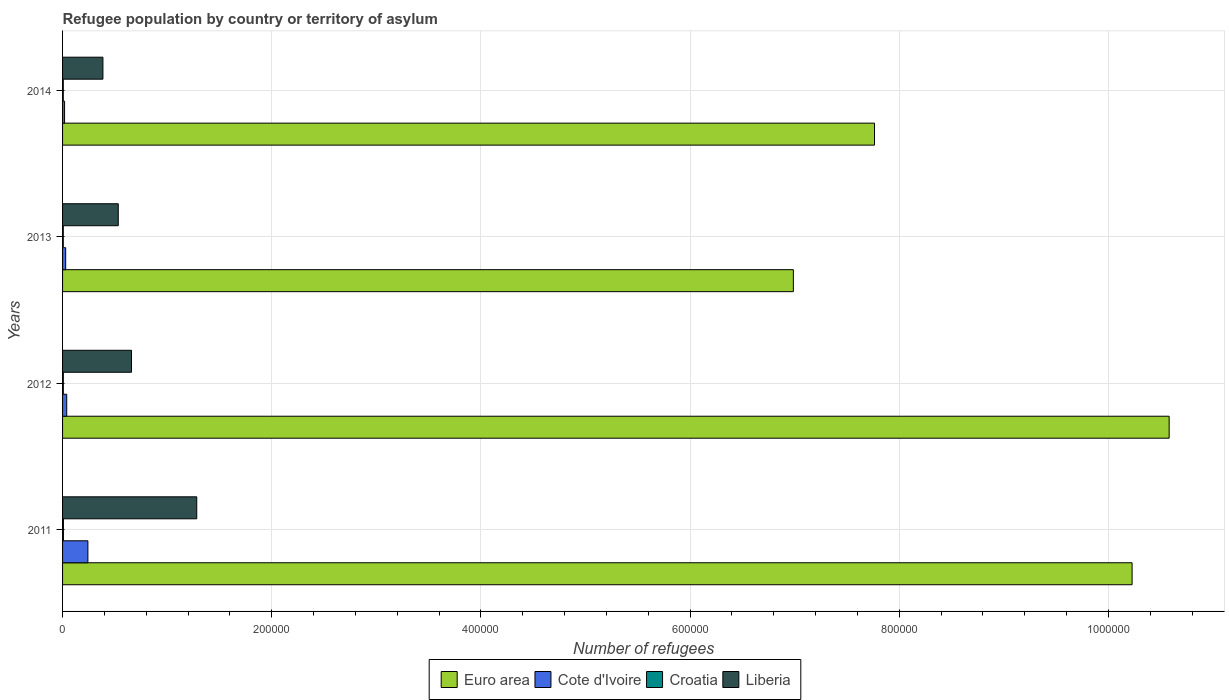How many groups of bars are there?
Offer a very short reply. 4. Are the number of bars per tick equal to the number of legend labels?
Provide a short and direct response. Yes. Are the number of bars on each tick of the Y-axis equal?
Ensure brevity in your answer.  Yes. How many bars are there on the 1st tick from the top?
Offer a terse response. 4. How many bars are there on the 1st tick from the bottom?
Give a very brief answer. 4. In how many cases, is the number of bars for a given year not equal to the number of legend labels?
Offer a terse response. 0. What is the number of refugees in Cote d'Ivoire in 2012?
Provide a short and direct response. 3980. Across all years, what is the maximum number of refugees in Euro area?
Make the answer very short. 1.06e+06. Across all years, what is the minimum number of refugees in Croatia?
Ensure brevity in your answer.  679. What is the total number of refugees in Liberia in the graph?
Your answer should be compact. 2.86e+05. What is the difference between the number of refugees in Croatia in 2011 and that in 2012?
Offer a very short reply. 100. What is the difference between the number of refugees in Cote d'Ivoire in 2011 and the number of refugees in Liberia in 2014?
Give a very brief answer. -1.44e+04. What is the average number of refugees in Cote d'Ivoire per year?
Make the answer very short. 8276.5. In the year 2011, what is the difference between the number of refugees in Cote d'Ivoire and number of refugees in Croatia?
Your answer should be very brief. 2.34e+04. What is the ratio of the number of refugees in Euro area in 2011 to that in 2014?
Provide a succinct answer. 1.32. Is the number of refugees in Euro area in 2012 less than that in 2013?
Your answer should be compact. No. Is the difference between the number of refugees in Cote d'Ivoire in 2011 and 2013 greater than the difference between the number of refugees in Croatia in 2011 and 2013?
Give a very brief answer. Yes. What is the difference between the highest and the second highest number of refugees in Euro area?
Offer a very short reply. 3.54e+04. What is the difference between the highest and the lowest number of refugees in Cote d'Ivoire?
Keep it short and to the point. 2.23e+04. In how many years, is the number of refugees in Croatia greater than the average number of refugees in Croatia taken over all years?
Make the answer very short. 1. What does the 2nd bar from the top in 2013 represents?
Ensure brevity in your answer.  Croatia. What does the 1st bar from the bottom in 2011 represents?
Offer a terse response. Euro area. Is it the case that in every year, the sum of the number of refugees in Croatia and number of refugees in Liberia is greater than the number of refugees in Euro area?
Give a very brief answer. No. How many bars are there?
Offer a terse response. 16. Are all the bars in the graph horizontal?
Give a very brief answer. Yes. What is the difference between two consecutive major ticks on the X-axis?
Offer a very short reply. 2.00e+05. Does the graph contain grids?
Your answer should be very brief. Yes. What is the title of the graph?
Provide a short and direct response. Refugee population by country or territory of asylum. What is the label or title of the X-axis?
Ensure brevity in your answer.  Number of refugees. What is the Number of refugees in Euro area in 2011?
Ensure brevity in your answer.  1.02e+06. What is the Number of refugees of Cote d'Ivoire in 2011?
Offer a terse response. 2.42e+04. What is the Number of refugees in Croatia in 2011?
Keep it short and to the point. 824. What is the Number of refugees in Liberia in 2011?
Your response must be concise. 1.28e+05. What is the Number of refugees in Euro area in 2012?
Offer a terse response. 1.06e+06. What is the Number of refugees of Cote d'Ivoire in 2012?
Ensure brevity in your answer.  3980. What is the Number of refugees of Croatia in 2012?
Your answer should be very brief. 724. What is the Number of refugees of Liberia in 2012?
Your response must be concise. 6.59e+04. What is the Number of refugees in Euro area in 2013?
Offer a very short reply. 6.99e+05. What is the Number of refugees of Cote d'Ivoire in 2013?
Keep it short and to the point. 2980. What is the Number of refugees in Croatia in 2013?
Ensure brevity in your answer.  684. What is the Number of refugees in Liberia in 2013?
Your answer should be very brief. 5.33e+04. What is the Number of refugees in Euro area in 2014?
Provide a short and direct response. 7.76e+05. What is the Number of refugees of Cote d'Ivoire in 2014?
Make the answer very short. 1925. What is the Number of refugees of Croatia in 2014?
Keep it short and to the point. 679. What is the Number of refugees of Liberia in 2014?
Keep it short and to the point. 3.86e+04. Across all years, what is the maximum Number of refugees in Euro area?
Make the answer very short. 1.06e+06. Across all years, what is the maximum Number of refugees in Cote d'Ivoire?
Make the answer very short. 2.42e+04. Across all years, what is the maximum Number of refugees of Croatia?
Make the answer very short. 824. Across all years, what is the maximum Number of refugees in Liberia?
Keep it short and to the point. 1.28e+05. Across all years, what is the minimum Number of refugees in Euro area?
Keep it short and to the point. 6.99e+05. Across all years, what is the minimum Number of refugees in Cote d'Ivoire?
Your response must be concise. 1925. Across all years, what is the minimum Number of refugees in Croatia?
Give a very brief answer. 679. Across all years, what is the minimum Number of refugees of Liberia?
Provide a succinct answer. 3.86e+04. What is the total Number of refugees in Euro area in the graph?
Ensure brevity in your answer.  3.56e+06. What is the total Number of refugees of Cote d'Ivoire in the graph?
Your answer should be compact. 3.31e+04. What is the total Number of refugees of Croatia in the graph?
Offer a very short reply. 2911. What is the total Number of refugees of Liberia in the graph?
Your response must be concise. 2.86e+05. What is the difference between the Number of refugees in Euro area in 2011 and that in 2012?
Provide a succinct answer. -3.54e+04. What is the difference between the Number of refugees of Cote d'Ivoire in 2011 and that in 2012?
Your response must be concise. 2.02e+04. What is the difference between the Number of refugees in Liberia in 2011 and that in 2012?
Your response must be concise. 6.24e+04. What is the difference between the Number of refugees of Euro area in 2011 and that in 2013?
Your response must be concise. 3.24e+05. What is the difference between the Number of refugees of Cote d'Ivoire in 2011 and that in 2013?
Keep it short and to the point. 2.12e+04. What is the difference between the Number of refugees of Croatia in 2011 and that in 2013?
Offer a very short reply. 140. What is the difference between the Number of refugees in Liberia in 2011 and that in 2013?
Ensure brevity in your answer.  7.50e+04. What is the difference between the Number of refugees of Euro area in 2011 and that in 2014?
Keep it short and to the point. 2.46e+05. What is the difference between the Number of refugees of Cote d'Ivoire in 2011 and that in 2014?
Provide a short and direct response. 2.23e+04. What is the difference between the Number of refugees in Croatia in 2011 and that in 2014?
Your response must be concise. 145. What is the difference between the Number of refugees of Liberia in 2011 and that in 2014?
Provide a short and direct response. 8.97e+04. What is the difference between the Number of refugees of Euro area in 2012 and that in 2013?
Provide a short and direct response. 3.59e+05. What is the difference between the Number of refugees of Croatia in 2012 and that in 2013?
Your response must be concise. 40. What is the difference between the Number of refugees in Liberia in 2012 and that in 2013?
Provide a short and direct response. 1.27e+04. What is the difference between the Number of refugees in Euro area in 2012 and that in 2014?
Your answer should be very brief. 2.82e+05. What is the difference between the Number of refugees of Cote d'Ivoire in 2012 and that in 2014?
Make the answer very short. 2055. What is the difference between the Number of refugees in Liberia in 2012 and that in 2014?
Offer a very short reply. 2.73e+04. What is the difference between the Number of refugees of Euro area in 2013 and that in 2014?
Offer a terse response. -7.76e+04. What is the difference between the Number of refugees of Cote d'Ivoire in 2013 and that in 2014?
Keep it short and to the point. 1055. What is the difference between the Number of refugees of Croatia in 2013 and that in 2014?
Ensure brevity in your answer.  5. What is the difference between the Number of refugees of Liberia in 2013 and that in 2014?
Offer a terse response. 1.47e+04. What is the difference between the Number of refugees in Euro area in 2011 and the Number of refugees in Cote d'Ivoire in 2012?
Give a very brief answer. 1.02e+06. What is the difference between the Number of refugees in Euro area in 2011 and the Number of refugees in Croatia in 2012?
Provide a short and direct response. 1.02e+06. What is the difference between the Number of refugees of Euro area in 2011 and the Number of refugees of Liberia in 2012?
Your answer should be very brief. 9.57e+05. What is the difference between the Number of refugees of Cote d'Ivoire in 2011 and the Number of refugees of Croatia in 2012?
Offer a very short reply. 2.35e+04. What is the difference between the Number of refugees in Cote d'Ivoire in 2011 and the Number of refugees in Liberia in 2012?
Your response must be concise. -4.17e+04. What is the difference between the Number of refugees in Croatia in 2011 and the Number of refugees in Liberia in 2012?
Provide a succinct answer. -6.51e+04. What is the difference between the Number of refugees of Euro area in 2011 and the Number of refugees of Cote d'Ivoire in 2013?
Your answer should be very brief. 1.02e+06. What is the difference between the Number of refugees in Euro area in 2011 and the Number of refugees in Croatia in 2013?
Your answer should be compact. 1.02e+06. What is the difference between the Number of refugees in Euro area in 2011 and the Number of refugees in Liberia in 2013?
Offer a very short reply. 9.69e+05. What is the difference between the Number of refugees in Cote d'Ivoire in 2011 and the Number of refugees in Croatia in 2013?
Offer a terse response. 2.35e+04. What is the difference between the Number of refugees of Cote d'Ivoire in 2011 and the Number of refugees of Liberia in 2013?
Offer a terse response. -2.90e+04. What is the difference between the Number of refugees in Croatia in 2011 and the Number of refugees in Liberia in 2013?
Provide a short and direct response. -5.24e+04. What is the difference between the Number of refugees in Euro area in 2011 and the Number of refugees in Cote d'Ivoire in 2014?
Provide a short and direct response. 1.02e+06. What is the difference between the Number of refugees of Euro area in 2011 and the Number of refugees of Croatia in 2014?
Provide a succinct answer. 1.02e+06. What is the difference between the Number of refugees in Euro area in 2011 and the Number of refugees in Liberia in 2014?
Keep it short and to the point. 9.84e+05. What is the difference between the Number of refugees in Cote d'Ivoire in 2011 and the Number of refugees in Croatia in 2014?
Your response must be concise. 2.35e+04. What is the difference between the Number of refugees in Cote d'Ivoire in 2011 and the Number of refugees in Liberia in 2014?
Ensure brevity in your answer.  -1.44e+04. What is the difference between the Number of refugees of Croatia in 2011 and the Number of refugees of Liberia in 2014?
Keep it short and to the point. -3.78e+04. What is the difference between the Number of refugees of Euro area in 2012 and the Number of refugees of Cote d'Ivoire in 2013?
Your answer should be compact. 1.06e+06. What is the difference between the Number of refugees in Euro area in 2012 and the Number of refugees in Croatia in 2013?
Make the answer very short. 1.06e+06. What is the difference between the Number of refugees of Euro area in 2012 and the Number of refugees of Liberia in 2013?
Offer a terse response. 1.00e+06. What is the difference between the Number of refugees of Cote d'Ivoire in 2012 and the Number of refugees of Croatia in 2013?
Your response must be concise. 3296. What is the difference between the Number of refugees of Cote d'Ivoire in 2012 and the Number of refugees of Liberia in 2013?
Provide a short and direct response. -4.93e+04. What is the difference between the Number of refugees in Croatia in 2012 and the Number of refugees in Liberia in 2013?
Offer a terse response. -5.25e+04. What is the difference between the Number of refugees of Euro area in 2012 and the Number of refugees of Cote d'Ivoire in 2014?
Ensure brevity in your answer.  1.06e+06. What is the difference between the Number of refugees in Euro area in 2012 and the Number of refugees in Croatia in 2014?
Keep it short and to the point. 1.06e+06. What is the difference between the Number of refugees of Euro area in 2012 and the Number of refugees of Liberia in 2014?
Keep it short and to the point. 1.02e+06. What is the difference between the Number of refugees in Cote d'Ivoire in 2012 and the Number of refugees in Croatia in 2014?
Provide a succinct answer. 3301. What is the difference between the Number of refugees of Cote d'Ivoire in 2012 and the Number of refugees of Liberia in 2014?
Make the answer very short. -3.46e+04. What is the difference between the Number of refugees of Croatia in 2012 and the Number of refugees of Liberia in 2014?
Make the answer very short. -3.79e+04. What is the difference between the Number of refugees of Euro area in 2013 and the Number of refugees of Cote d'Ivoire in 2014?
Offer a very short reply. 6.97e+05. What is the difference between the Number of refugees of Euro area in 2013 and the Number of refugees of Croatia in 2014?
Keep it short and to the point. 6.98e+05. What is the difference between the Number of refugees in Euro area in 2013 and the Number of refugees in Liberia in 2014?
Your answer should be very brief. 6.60e+05. What is the difference between the Number of refugees in Cote d'Ivoire in 2013 and the Number of refugees in Croatia in 2014?
Provide a short and direct response. 2301. What is the difference between the Number of refugees in Cote d'Ivoire in 2013 and the Number of refugees in Liberia in 2014?
Provide a short and direct response. -3.56e+04. What is the difference between the Number of refugees in Croatia in 2013 and the Number of refugees in Liberia in 2014?
Provide a succinct answer. -3.79e+04. What is the average Number of refugees of Euro area per year?
Your answer should be compact. 8.89e+05. What is the average Number of refugees of Cote d'Ivoire per year?
Offer a terse response. 8276.5. What is the average Number of refugees in Croatia per year?
Provide a succinct answer. 727.75. What is the average Number of refugees of Liberia per year?
Make the answer very short. 7.15e+04. In the year 2011, what is the difference between the Number of refugees of Euro area and Number of refugees of Cote d'Ivoire?
Ensure brevity in your answer.  9.98e+05. In the year 2011, what is the difference between the Number of refugees in Euro area and Number of refugees in Croatia?
Your response must be concise. 1.02e+06. In the year 2011, what is the difference between the Number of refugees of Euro area and Number of refugees of Liberia?
Offer a terse response. 8.94e+05. In the year 2011, what is the difference between the Number of refugees in Cote d'Ivoire and Number of refugees in Croatia?
Give a very brief answer. 2.34e+04. In the year 2011, what is the difference between the Number of refugees in Cote d'Ivoire and Number of refugees in Liberia?
Provide a short and direct response. -1.04e+05. In the year 2011, what is the difference between the Number of refugees of Croatia and Number of refugees of Liberia?
Keep it short and to the point. -1.27e+05. In the year 2012, what is the difference between the Number of refugees of Euro area and Number of refugees of Cote d'Ivoire?
Your answer should be compact. 1.05e+06. In the year 2012, what is the difference between the Number of refugees in Euro area and Number of refugees in Croatia?
Your response must be concise. 1.06e+06. In the year 2012, what is the difference between the Number of refugees in Euro area and Number of refugees in Liberia?
Provide a short and direct response. 9.92e+05. In the year 2012, what is the difference between the Number of refugees of Cote d'Ivoire and Number of refugees of Croatia?
Keep it short and to the point. 3256. In the year 2012, what is the difference between the Number of refugees in Cote d'Ivoire and Number of refugees in Liberia?
Make the answer very short. -6.19e+04. In the year 2012, what is the difference between the Number of refugees in Croatia and Number of refugees in Liberia?
Provide a short and direct response. -6.52e+04. In the year 2013, what is the difference between the Number of refugees in Euro area and Number of refugees in Cote d'Ivoire?
Your answer should be very brief. 6.96e+05. In the year 2013, what is the difference between the Number of refugees in Euro area and Number of refugees in Croatia?
Provide a succinct answer. 6.98e+05. In the year 2013, what is the difference between the Number of refugees of Euro area and Number of refugees of Liberia?
Offer a terse response. 6.45e+05. In the year 2013, what is the difference between the Number of refugees in Cote d'Ivoire and Number of refugees in Croatia?
Your response must be concise. 2296. In the year 2013, what is the difference between the Number of refugees in Cote d'Ivoire and Number of refugees in Liberia?
Your response must be concise. -5.03e+04. In the year 2013, what is the difference between the Number of refugees of Croatia and Number of refugees of Liberia?
Make the answer very short. -5.26e+04. In the year 2014, what is the difference between the Number of refugees in Euro area and Number of refugees in Cote d'Ivoire?
Your answer should be very brief. 7.74e+05. In the year 2014, what is the difference between the Number of refugees in Euro area and Number of refugees in Croatia?
Your answer should be very brief. 7.76e+05. In the year 2014, what is the difference between the Number of refugees of Euro area and Number of refugees of Liberia?
Your answer should be compact. 7.38e+05. In the year 2014, what is the difference between the Number of refugees in Cote d'Ivoire and Number of refugees in Croatia?
Offer a very short reply. 1246. In the year 2014, what is the difference between the Number of refugees in Cote d'Ivoire and Number of refugees in Liberia?
Keep it short and to the point. -3.67e+04. In the year 2014, what is the difference between the Number of refugees in Croatia and Number of refugees in Liberia?
Keep it short and to the point. -3.79e+04. What is the ratio of the Number of refugees in Euro area in 2011 to that in 2012?
Your answer should be very brief. 0.97. What is the ratio of the Number of refugees of Cote d'Ivoire in 2011 to that in 2012?
Your response must be concise. 6.09. What is the ratio of the Number of refugees of Croatia in 2011 to that in 2012?
Offer a terse response. 1.14. What is the ratio of the Number of refugees of Liberia in 2011 to that in 2012?
Give a very brief answer. 1.95. What is the ratio of the Number of refugees of Euro area in 2011 to that in 2013?
Your answer should be very brief. 1.46. What is the ratio of the Number of refugees in Cote d'Ivoire in 2011 to that in 2013?
Make the answer very short. 8.13. What is the ratio of the Number of refugees in Croatia in 2011 to that in 2013?
Provide a succinct answer. 1.2. What is the ratio of the Number of refugees of Liberia in 2011 to that in 2013?
Offer a terse response. 2.41. What is the ratio of the Number of refugees in Euro area in 2011 to that in 2014?
Keep it short and to the point. 1.32. What is the ratio of the Number of refugees of Cote d'Ivoire in 2011 to that in 2014?
Provide a short and direct response. 12.58. What is the ratio of the Number of refugees in Croatia in 2011 to that in 2014?
Offer a terse response. 1.21. What is the ratio of the Number of refugees in Liberia in 2011 to that in 2014?
Provide a succinct answer. 3.32. What is the ratio of the Number of refugees in Euro area in 2012 to that in 2013?
Your answer should be compact. 1.51. What is the ratio of the Number of refugees in Cote d'Ivoire in 2012 to that in 2013?
Offer a very short reply. 1.34. What is the ratio of the Number of refugees of Croatia in 2012 to that in 2013?
Ensure brevity in your answer.  1.06. What is the ratio of the Number of refugees of Liberia in 2012 to that in 2013?
Your answer should be very brief. 1.24. What is the ratio of the Number of refugees in Euro area in 2012 to that in 2014?
Your answer should be compact. 1.36. What is the ratio of the Number of refugees of Cote d'Ivoire in 2012 to that in 2014?
Give a very brief answer. 2.07. What is the ratio of the Number of refugees of Croatia in 2012 to that in 2014?
Give a very brief answer. 1.07. What is the ratio of the Number of refugees in Liberia in 2012 to that in 2014?
Provide a succinct answer. 1.71. What is the ratio of the Number of refugees in Euro area in 2013 to that in 2014?
Offer a very short reply. 0.9. What is the ratio of the Number of refugees of Cote d'Ivoire in 2013 to that in 2014?
Provide a short and direct response. 1.55. What is the ratio of the Number of refugees in Croatia in 2013 to that in 2014?
Give a very brief answer. 1.01. What is the ratio of the Number of refugees of Liberia in 2013 to that in 2014?
Provide a short and direct response. 1.38. What is the difference between the highest and the second highest Number of refugees in Euro area?
Make the answer very short. 3.54e+04. What is the difference between the highest and the second highest Number of refugees in Cote d'Ivoire?
Make the answer very short. 2.02e+04. What is the difference between the highest and the second highest Number of refugees in Liberia?
Ensure brevity in your answer.  6.24e+04. What is the difference between the highest and the lowest Number of refugees in Euro area?
Provide a short and direct response. 3.59e+05. What is the difference between the highest and the lowest Number of refugees of Cote d'Ivoire?
Provide a succinct answer. 2.23e+04. What is the difference between the highest and the lowest Number of refugees of Croatia?
Keep it short and to the point. 145. What is the difference between the highest and the lowest Number of refugees in Liberia?
Provide a succinct answer. 8.97e+04. 